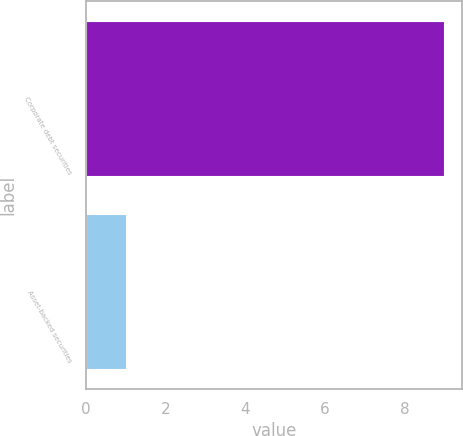Convert chart to OTSL. <chart><loc_0><loc_0><loc_500><loc_500><bar_chart><fcel>Corporate debt securities<fcel>Asset-backed securities<nl><fcel>9<fcel>1<nl></chart> 